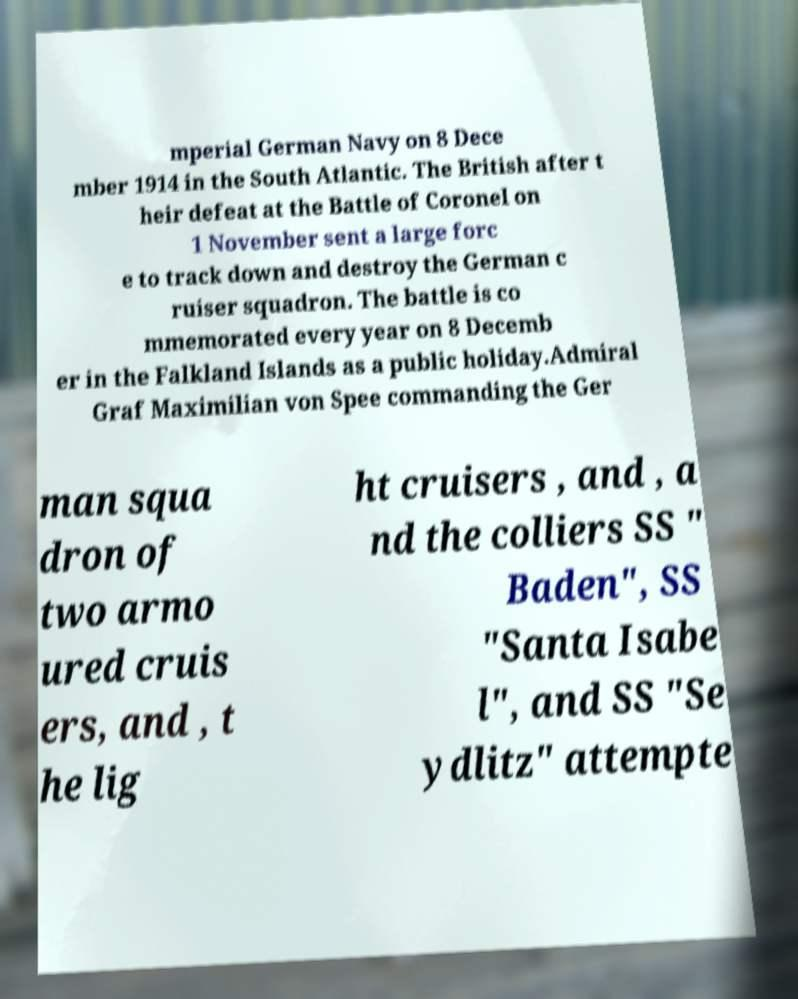There's text embedded in this image that I need extracted. Can you transcribe it verbatim? mperial German Navy on 8 Dece mber 1914 in the South Atlantic. The British after t heir defeat at the Battle of Coronel on 1 November sent a large forc e to track down and destroy the German c ruiser squadron. The battle is co mmemorated every year on 8 Decemb er in the Falkland Islands as a public holiday.Admiral Graf Maximilian von Spee commanding the Ger man squa dron of two armo ured cruis ers, and , t he lig ht cruisers , and , a nd the colliers SS " Baden", SS "Santa Isabe l", and SS "Se ydlitz" attempte 